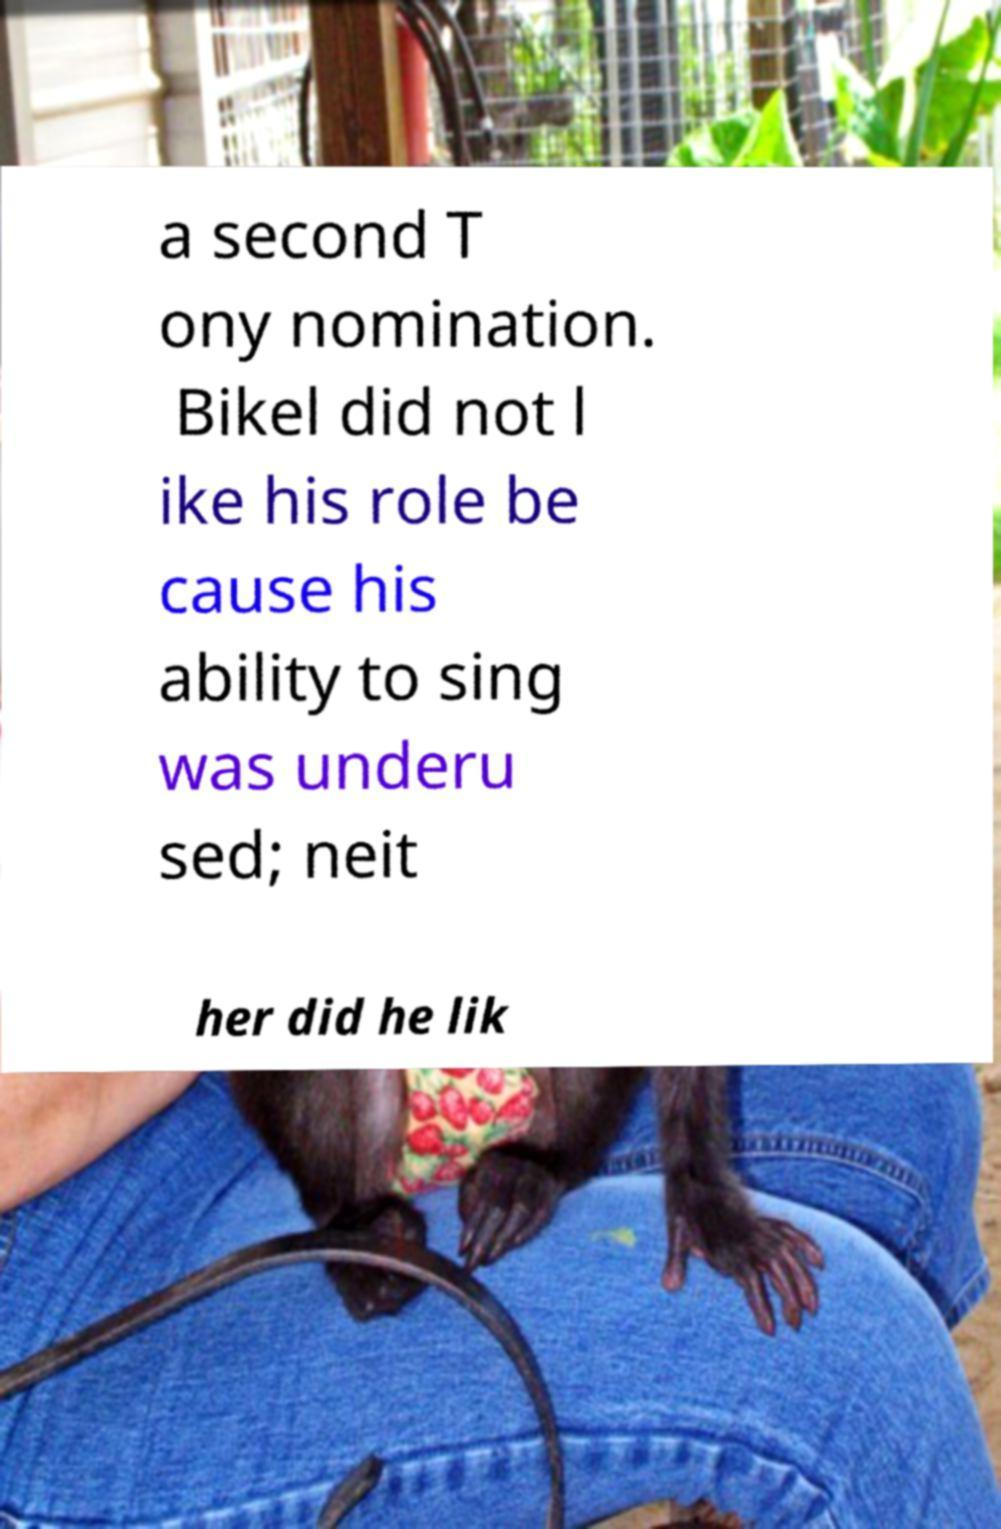For documentation purposes, I need the text within this image transcribed. Could you provide that? a second T ony nomination. Bikel did not l ike his role be cause his ability to sing was underu sed; neit her did he lik 